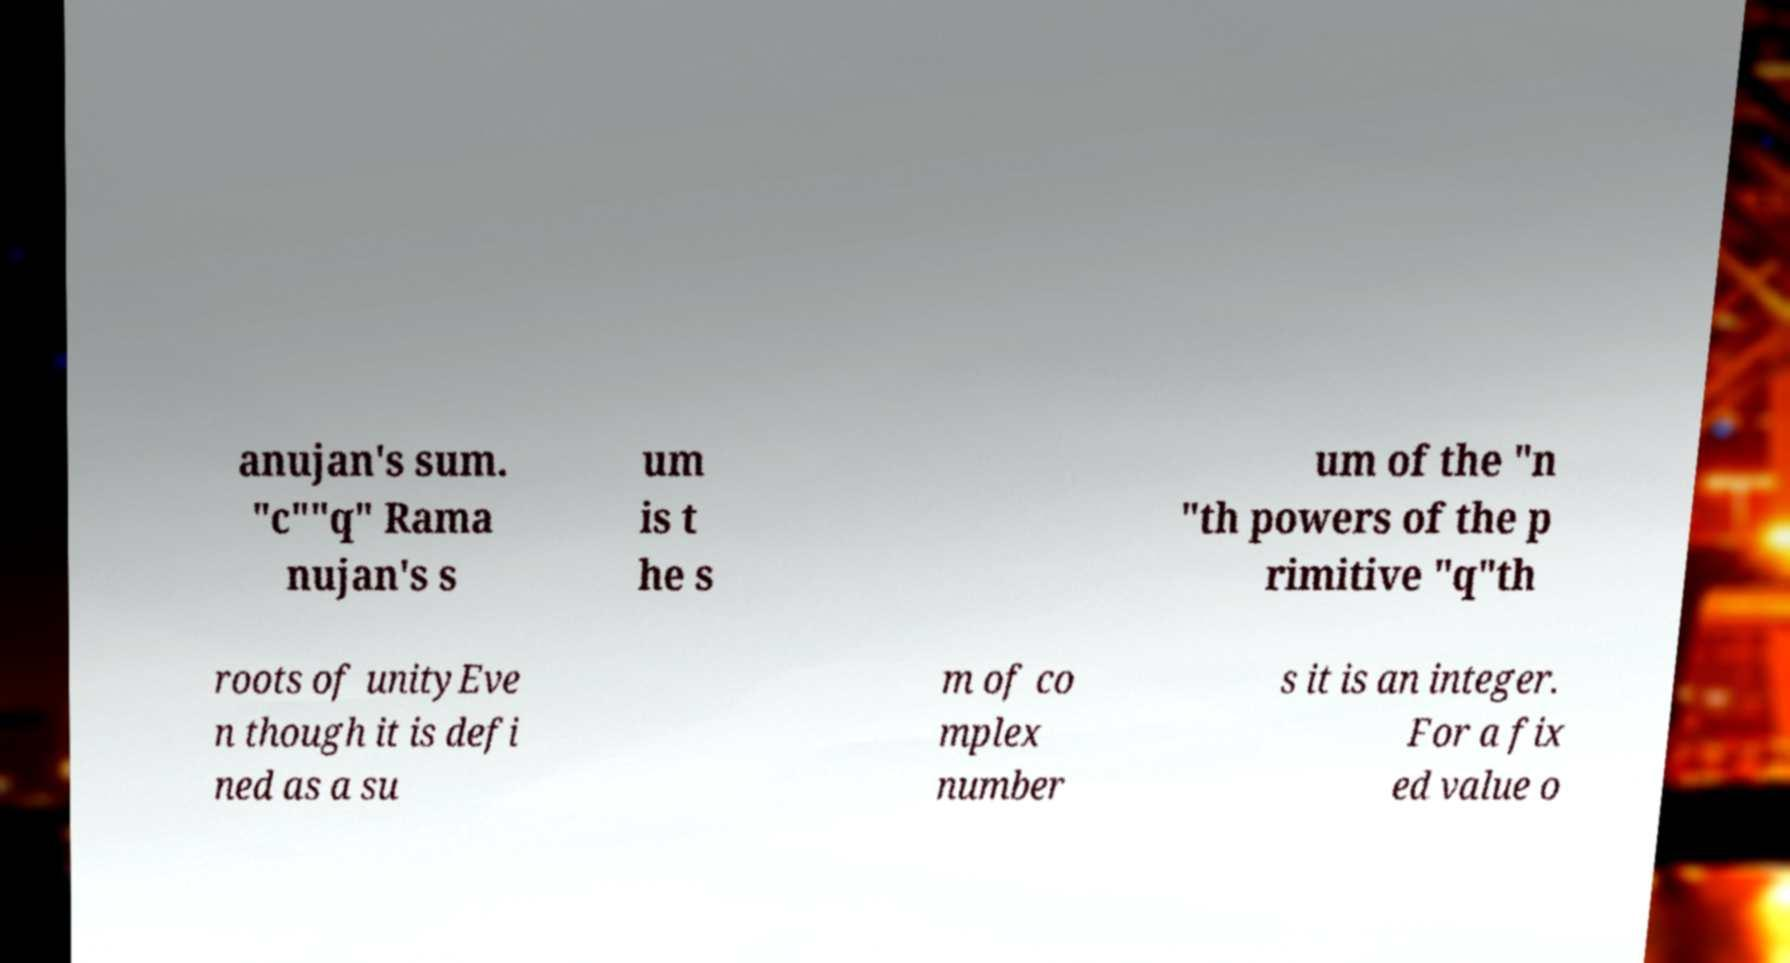Could you extract and type out the text from this image? anujan's sum. "c""q" Rama nujan's s um is t he s um of the "n "th powers of the p rimitive "q"th roots of unityEve n though it is defi ned as a su m of co mplex number s it is an integer. For a fix ed value o 